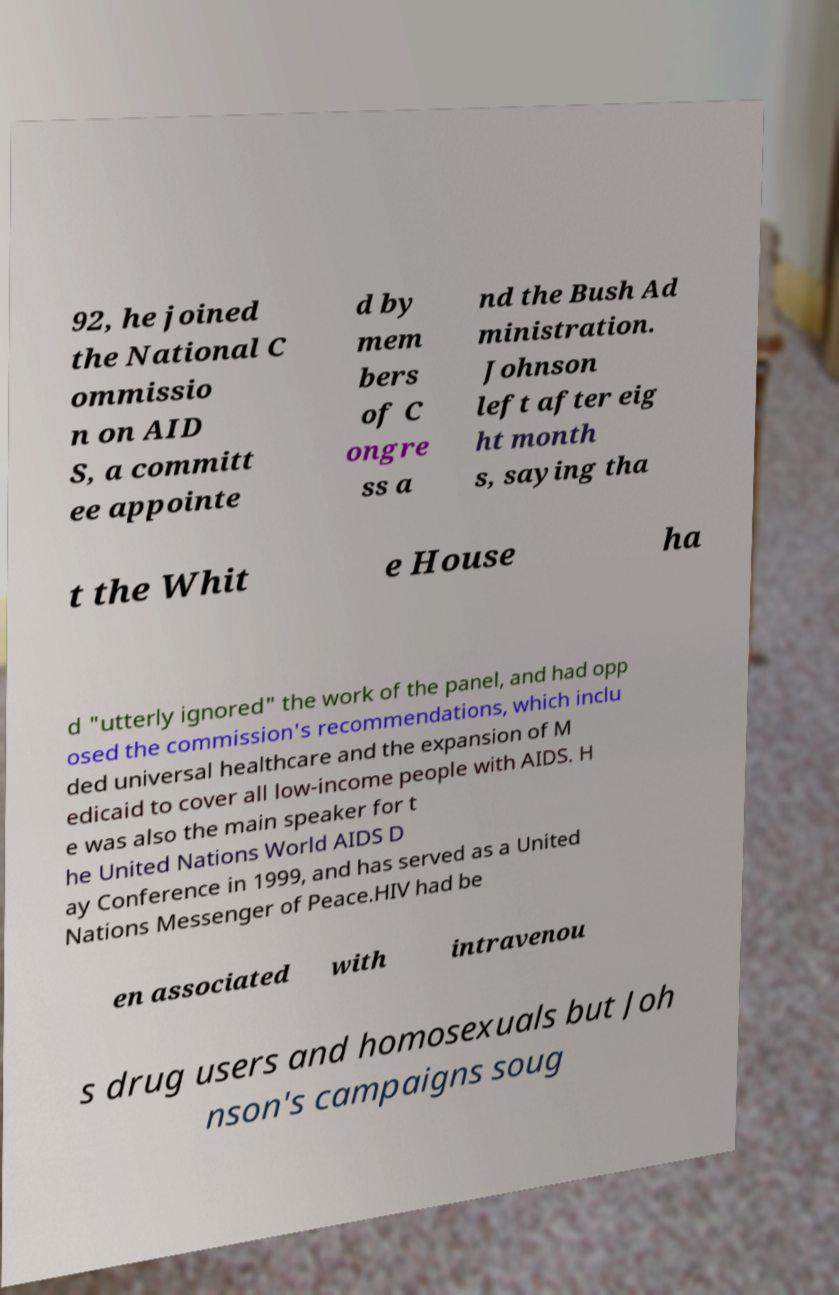Please identify and transcribe the text found in this image. 92, he joined the National C ommissio n on AID S, a committ ee appointe d by mem bers of C ongre ss a nd the Bush Ad ministration. Johnson left after eig ht month s, saying tha t the Whit e House ha d "utterly ignored" the work of the panel, and had opp osed the commission's recommendations, which inclu ded universal healthcare and the expansion of M edicaid to cover all low-income people with AIDS. H e was also the main speaker for t he United Nations World AIDS D ay Conference in 1999, and has served as a United Nations Messenger of Peace.HIV had be en associated with intravenou s drug users and homosexuals but Joh nson's campaigns soug 